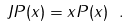Convert formula to latex. <formula><loc_0><loc_0><loc_500><loc_500>J P ( x ) = x P ( x ) \ .</formula> 